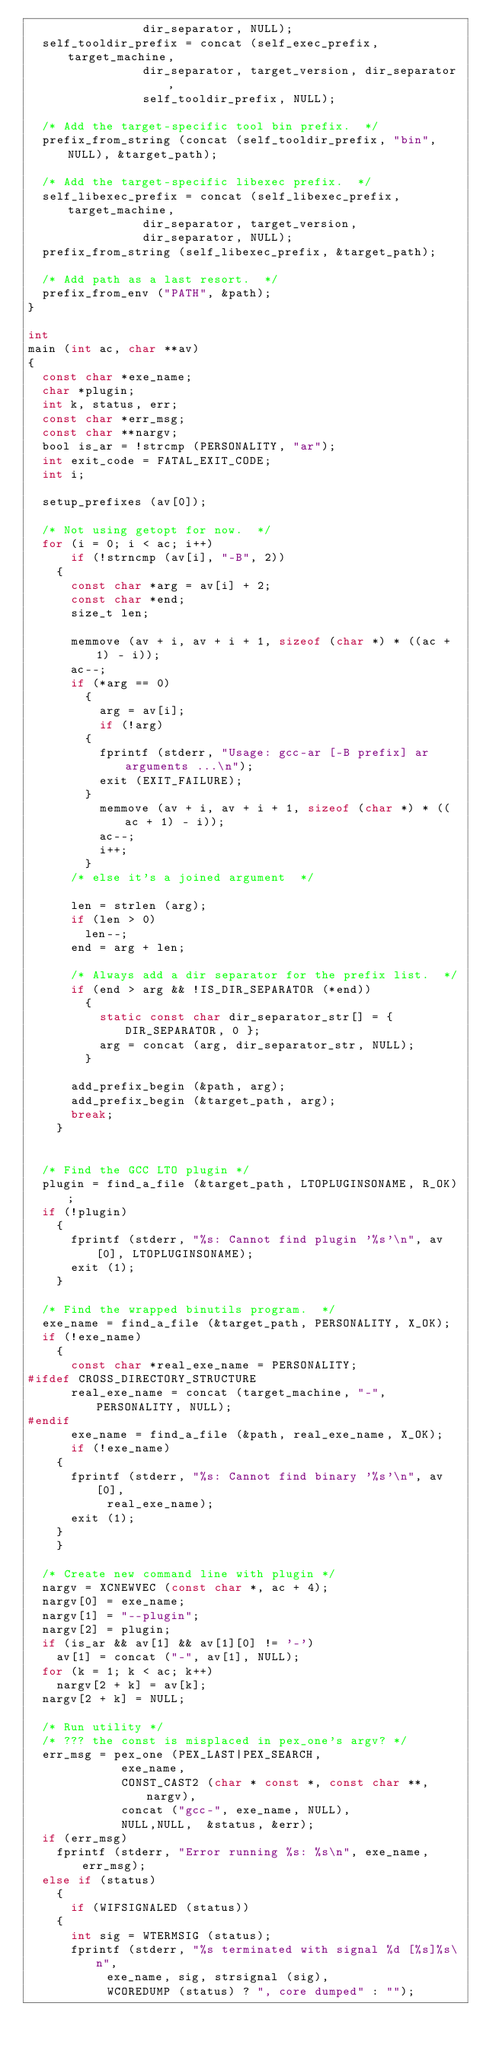<code> <loc_0><loc_0><loc_500><loc_500><_C_>				dir_separator, NULL);
  self_tooldir_prefix = concat (self_exec_prefix, target_machine, 
				dir_separator, target_version, dir_separator,
				self_tooldir_prefix, NULL);

  /* Add the target-specific tool bin prefix.  */
  prefix_from_string (concat (self_tooldir_prefix, "bin", NULL), &target_path);

  /* Add the target-specific libexec prefix.  */
  self_libexec_prefix = concat (self_libexec_prefix, target_machine, 
				dir_separator, target_version,
				dir_separator, NULL);
  prefix_from_string (self_libexec_prefix, &target_path);

  /* Add path as a last resort.  */
  prefix_from_env ("PATH", &path);
}

int 
main (int ac, char **av)
{
  const char *exe_name;
  char *plugin;
  int k, status, err;
  const char *err_msg;
  const char **nargv;
  bool is_ar = !strcmp (PERSONALITY, "ar");
  int exit_code = FATAL_EXIT_CODE;
  int i;

  setup_prefixes (av[0]);

  /* Not using getopt for now.  */
  for (i = 0; i < ac; i++)
      if (!strncmp (av[i], "-B", 2))
	{
	  const char *arg = av[i] + 2;
	  const char *end;
	  size_t len;

	  memmove (av + i, av + i + 1, sizeof (char *) * ((ac + 1) - i));
	  ac--;
	  if (*arg == 0)
	    {
	      arg = av[i];
	      if (!arg)
		{
		  fprintf (stderr, "Usage: gcc-ar [-B prefix] ar arguments ...\n");
		  exit (EXIT_FAILURE);
		}
	      memmove (av + i, av + i + 1, sizeof (char *) * ((ac + 1) - i));
	      ac--;
	      i++;
	    }
	  /* else it's a joined argument  */

	  len = strlen (arg);
	  if (len > 0)
	    len--;
	  end = arg + len;

	  /* Always add a dir separator for the prefix list.  */
	  if (end > arg && !IS_DIR_SEPARATOR (*end))
	    {
	      static const char dir_separator_str[] = { DIR_SEPARATOR, 0 };
	      arg = concat (arg, dir_separator_str, NULL);
	    }

	  add_prefix_begin (&path, arg);
	  add_prefix_begin (&target_path, arg);
	  break;
	}


  /* Find the GCC LTO plugin */
  plugin = find_a_file (&target_path, LTOPLUGINSONAME, R_OK);
  if (!plugin)
    {
      fprintf (stderr, "%s: Cannot find plugin '%s'\n", av[0], LTOPLUGINSONAME);
      exit (1);
    }

  /* Find the wrapped binutils program.  */
  exe_name = find_a_file (&target_path, PERSONALITY, X_OK);
  if (!exe_name)
    {
      const char *real_exe_name = PERSONALITY;
#ifdef CROSS_DIRECTORY_STRUCTURE
      real_exe_name = concat (target_machine, "-", PERSONALITY, NULL);
#endif
      exe_name = find_a_file (&path, real_exe_name, X_OK);
      if (!exe_name)
	{
	  fprintf (stderr, "%s: Cannot find binary '%s'\n", av[0],
		   real_exe_name);
	  exit (1);
	}
    }

  /* Create new command line with plugin */
  nargv = XCNEWVEC (const char *, ac + 4);
  nargv[0] = exe_name;
  nargv[1] = "--plugin";
  nargv[2] = plugin;
  if (is_ar && av[1] && av[1][0] != '-')
    av[1] = concat ("-", av[1], NULL);
  for (k = 1; k < ac; k++)
    nargv[2 + k] = av[k];
  nargv[2 + k] = NULL;

  /* Run utility */
  /* ??? the const is misplaced in pex_one's argv? */
  err_msg = pex_one (PEX_LAST|PEX_SEARCH, 
		     exe_name, 
		     CONST_CAST2 (char * const *, const char **, nargv),
		     concat ("gcc-", exe_name, NULL),
		     NULL,NULL,  &status, &err);
  if (err_msg) 
    fprintf (stderr, "Error running %s: %s\n", exe_name, err_msg);
  else if (status)
    {
      if (WIFSIGNALED (status))
	{
	  int sig = WTERMSIG (status);
	  fprintf (stderr, "%s terminated with signal %d [%s]%s\n",
		   exe_name, sig, strsignal (sig),
		   WCOREDUMP (status) ? ", core dumped" : "");</code> 